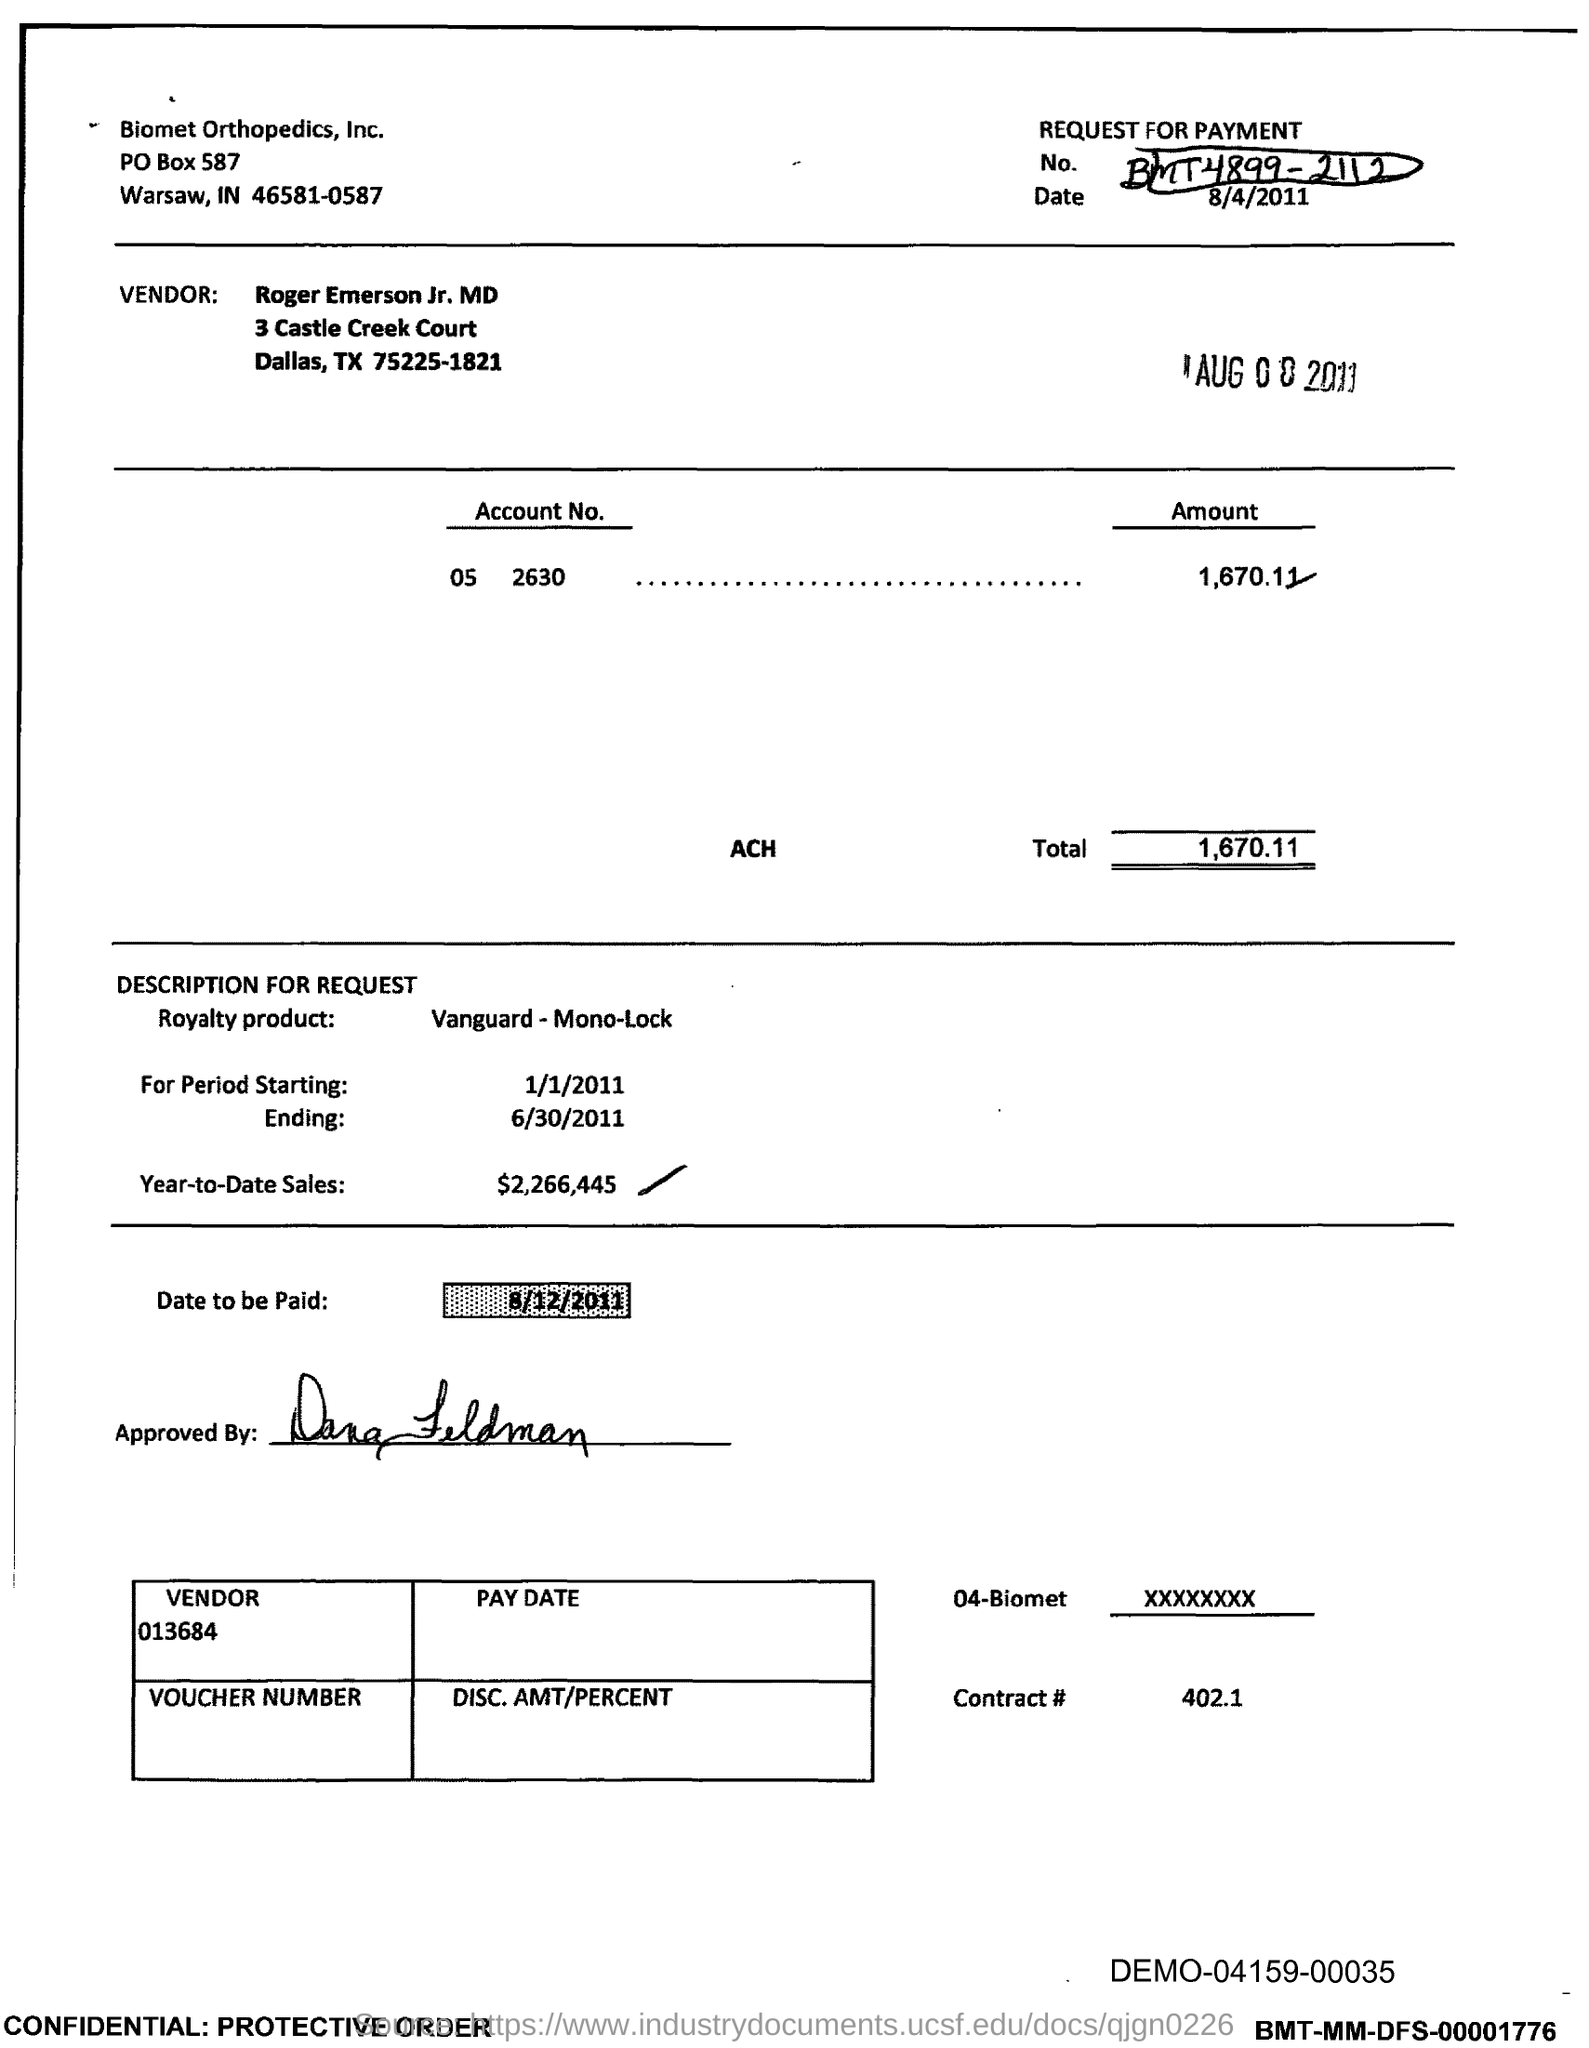Mention a couple of crucial points in this snapshot. The vendor number provided in the document is 013684... Please provide the payment request number, which is BMT4899 - 2112. The total amount mentioned in the document is 1,670.11. The vendor mentioned in the document is Roger Emerson Jr. MD. The end date of the royalty period is June 30, 2011. 